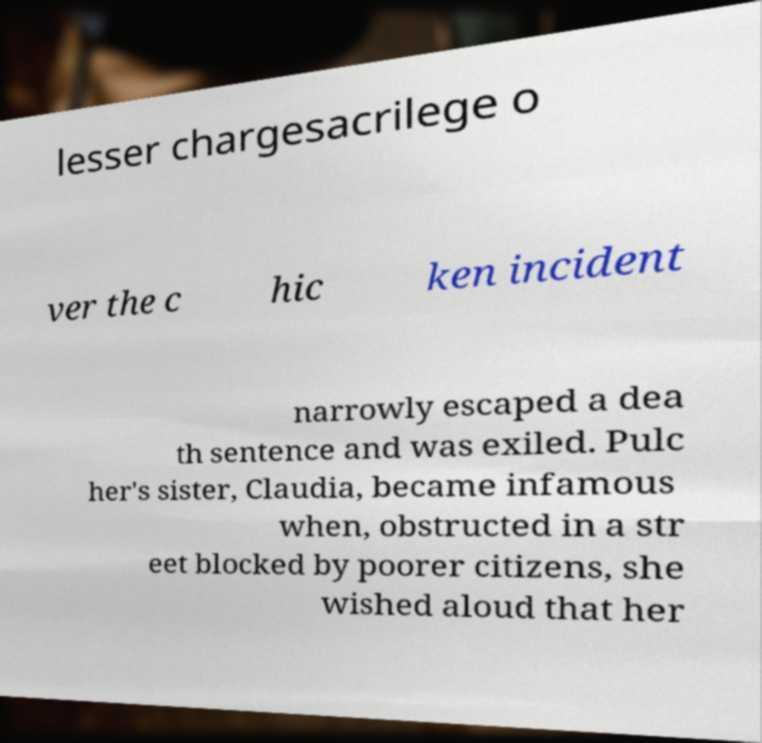Can you read and provide the text displayed in the image?This photo seems to have some interesting text. Can you extract and type it out for me? lesser chargesacrilege o ver the c hic ken incident narrowly escaped a dea th sentence and was exiled. Pulc her's sister, Claudia, became infamous when, obstructed in a str eet blocked by poorer citizens, she wished aloud that her 